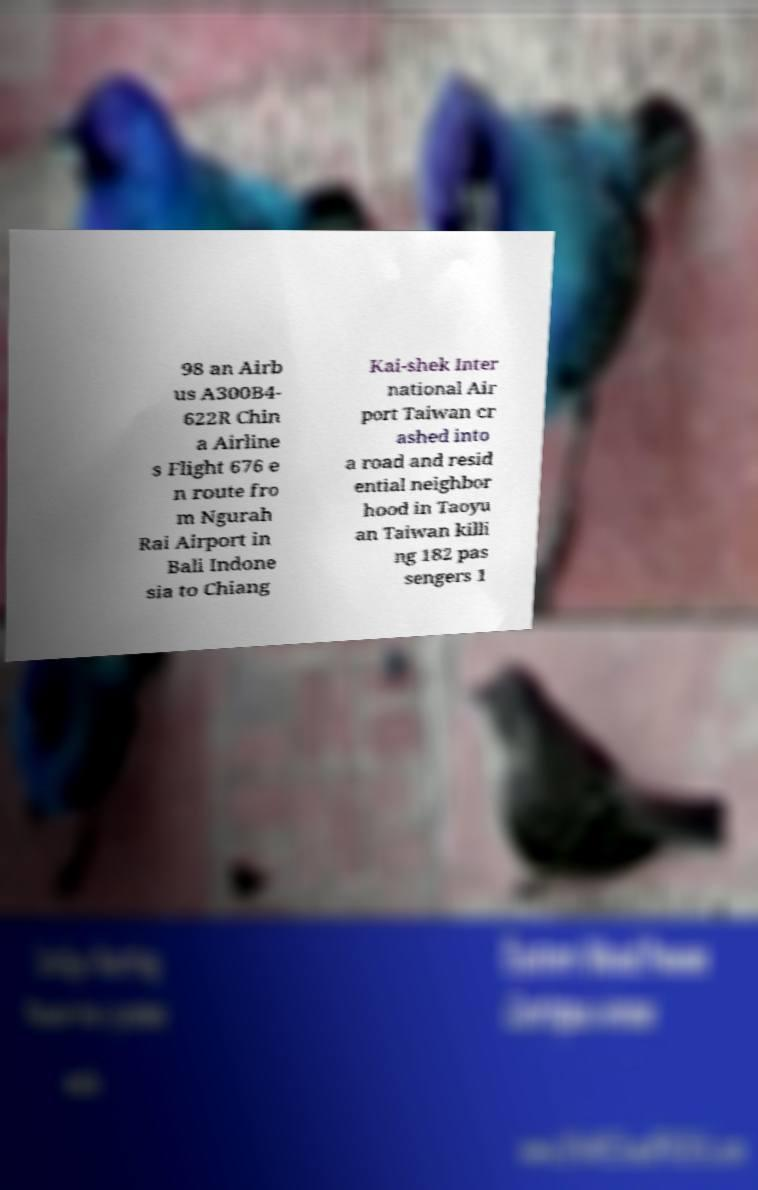What messages or text are displayed in this image? I need them in a readable, typed format. 98 an Airb us A300B4- 622R Chin a Airline s Flight 676 e n route fro m Ngurah Rai Airport in Bali Indone sia to Chiang Kai-shek Inter national Air port Taiwan cr ashed into a road and resid ential neighbor hood in Taoyu an Taiwan killi ng 182 pas sengers 1 